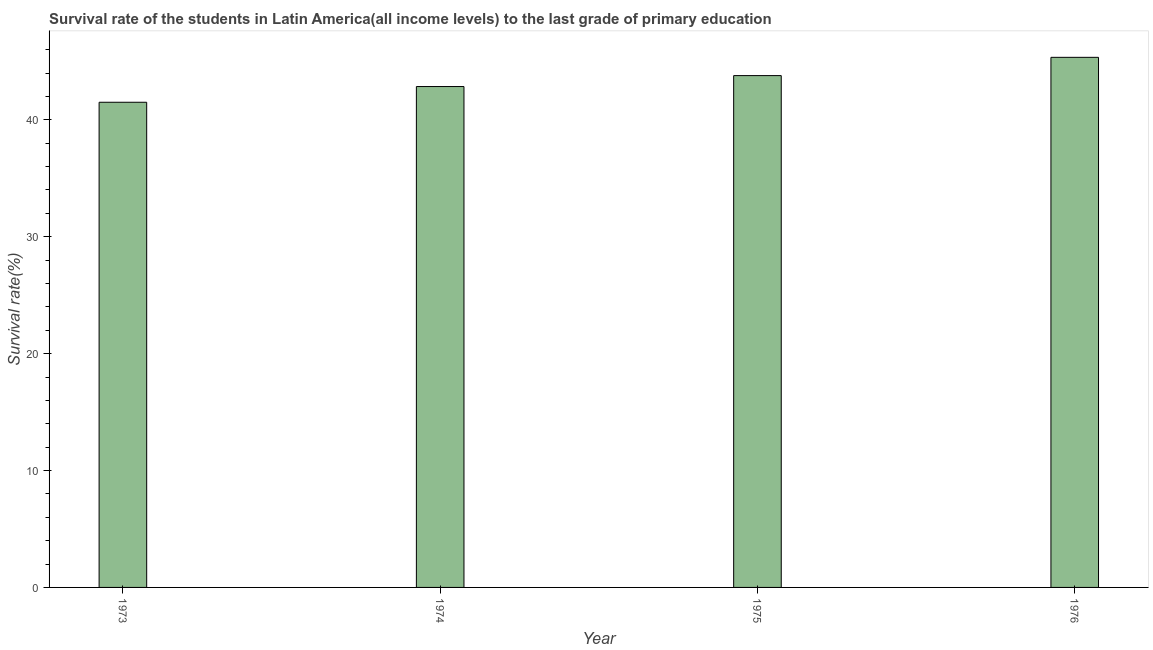Does the graph contain any zero values?
Keep it short and to the point. No. What is the title of the graph?
Keep it short and to the point. Survival rate of the students in Latin America(all income levels) to the last grade of primary education. What is the label or title of the X-axis?
Provide a short and direct response. Year. What is the label or title of the Y-axis?
Ensure brevity in your answer.  Survival rate(%). What is the survival rate in primary education in 1976?
Make the answer very short. 45.35. Across all years, what is the maximum survival rate in primary education?
Provide a short and direct response. 45.35. Across all years, what is the minimum survival rate in primary education?
Offer a terse response. 41.5. In which year was the survival rate in primary education maximum?
Provide a succinct answer. 1976. In which year was the survival rate in primary education minimum?
Offer a terse response. 1973. What is the sum of the survival rate in primary education?
Offer a terse response. 173.48. What is the difference between the survival rate in primary education in 1973 and 1974?
Provide a short and direct response. -1.34. What is the average survival rate in primary education per year?
Your answer should be compact. 43.37. What is the median survival rate in primary education?
Your answer should be compact. 43.32. In how many years, is the survival rate in primary education greater than 30 %?
Your response must be concise. 4. What is the difference between the highest and the second highest survival rate in primary education?
Make the answer very short. 1.56. Is the sum of the survival rate in primary education in 1975 and 1976 greater than the maximum survival rate in primary education across all years?
Your answer should be very brief. Yes. What is the difference between the highest and the lowest survival rate in primary education?
Provide a short and direct response. 3.84. In how many years, is the survival rate in primary education greater than the average survival rate in primary education taken over all years?
Keep it short and to the point. 2. What is the Survival rate(%) of 1973?
Offer a terse response. 41.5. What is the Survival rate(%) in 1974?
Keep it short and to the point. 42.85. What is the Survival rate(%) in 1975?
Ensure brevity in your answer.  43.78. What is the Survival rate(%) of 1976?
Provide a short and direct response. 45.35. What is the difference between the Survival rate(%) in 1973 and 1974?
Give a very brief answer. -1.34. What is the difference between the Survival rate(%) in 1973 and 1975?
Ensure brevity in your answer.  -2.28. What is the difference between the Survival rate(%) in 1973 and 1976?
Give a very brief answer. -3.84. What is the difference between the Survival rate(%) in 1974 and 1975?
Offer a very short reply. -0.94. What is the difference between the Survival rate(%) in 1974 and 1976?
Give a very brief answer. -2.5. What is the difference between the Survival rate(%) in 1975 and 1976?
Offer a terse response. -1.56. What is the ratio of the Survival rate(%) in 1973 to that in 1974?
Keep it short and to the point. 0.97. What is the ratio of the Survival rate(%) in 1973 to that in 1975?
Keep it short and to the point. 0.95. What is the ratio of the Survival rate(%) in 1973 to that in 1976?
Your response must be concise. 0.92. What is the ratio of the Survival rate(%) in 1974 to that in 1976?
Offer a terse response. 0.94. What is the ratio of the Survival rate(%) in 1975 to that in 1976?
Your answer should be compact. 0.97. 